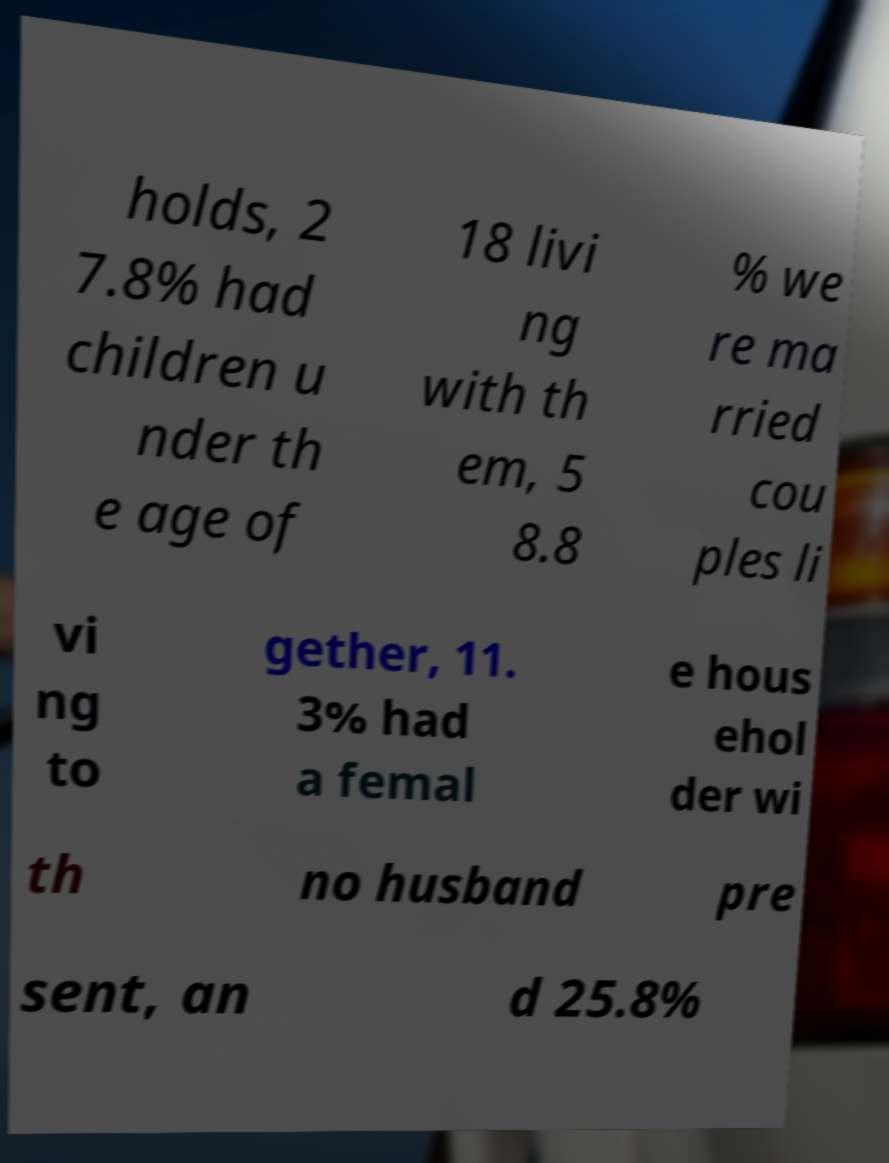There's text embedded in this image that I need extracted. Can you transcribe it verbatim? holds, 2 7.8% had children u nder th e age of 18 livi ng with th em, 5 8.8 % we re ma rried cou ples li vi ng to gether, 11. 3% had a femal e hous ehol der wi th no husband pre sent, an d 25.8% 